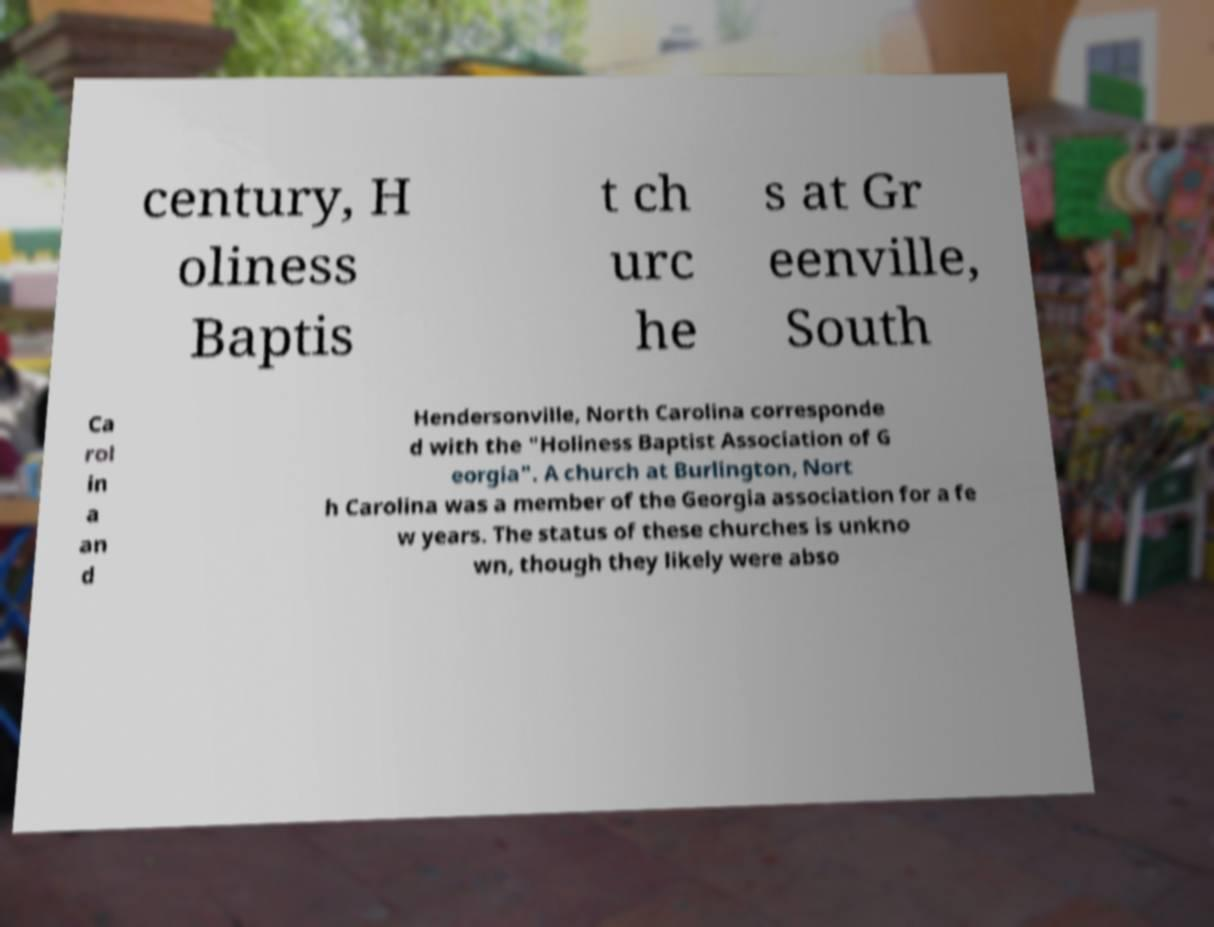Could you extract and type out the text from this image? century, H oliness Baptis t ch urc he s at Gr eenville, South Ca rol in a an d Hendersonville, North Carolina corresponde d with the "Holiness Baptist Association of G eorgia". A church at Burlington, Nort h Carolina was a member of the Georgia association for a fe w years. The status of these churches is unkno wn, though they likely were abso 